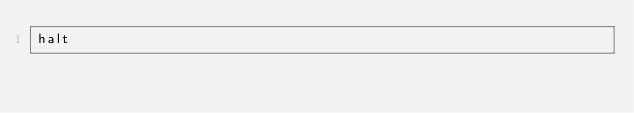<code> <loc_0><loc_0><loc_500><loc_500><_Forth_>halt
</code> 